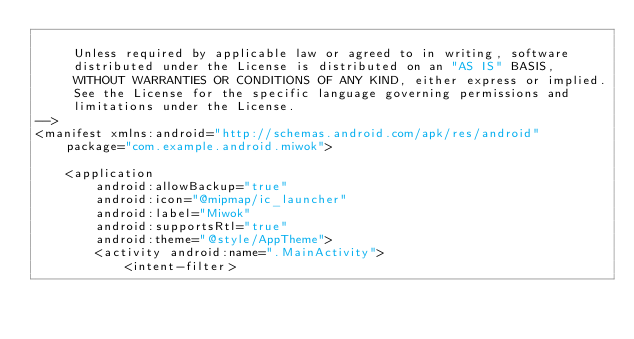Convert code to text. <code><loc_0><loc_0><loc_500><loc_500><_XML_>
     Unless required by applicable law or agreed to in writing, software
     distributed under the License is distributed on an "AS IS" BASIS,
     WITHOUT WARRANTIES OR CONDITIONS OF ANY KIND, either express or implied.
     See the License for the specific language governing permissions and
     limitations under the License.
-->
<manifest xmlns:android="http://schemas.android.com/apk/res/android"
    package="com.example.android.miwok">

    <application
        android:allowBackup="true"
        android:icon="@mipmap/ic_launcher"
        android:label="Miwok"
        android:supportsRtl="true"
        android:theme="@style/AppTheme">
        <activity android:name=".MainActivity">
            <intent-filter></code> 